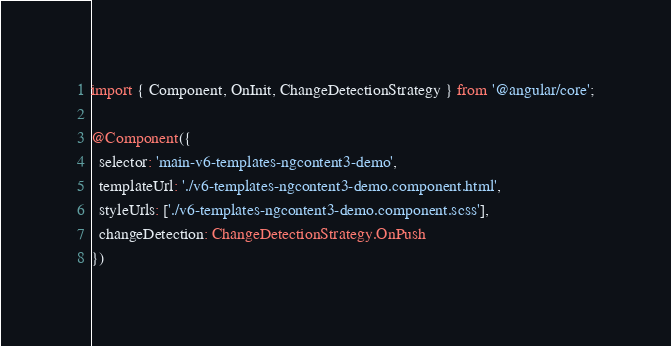Convert code to text. <code><loc_0><loc_0><loc_500><loc_500><_TypeScript_>import { Component, OnInit, ChangeDetectionStrategy } from '@angular/core';

@Component({
  selector: 'main-v6-templates-ngcontent3-demo',
  templateUrl: './v6-templates-ngcontent3-demo.component.html',
  styleUrls: ['./v6-templates-ngcontent3-demo.component.scss'],
  changeDetection: ChangeDetectionStrategy.OnPush
})</code> 